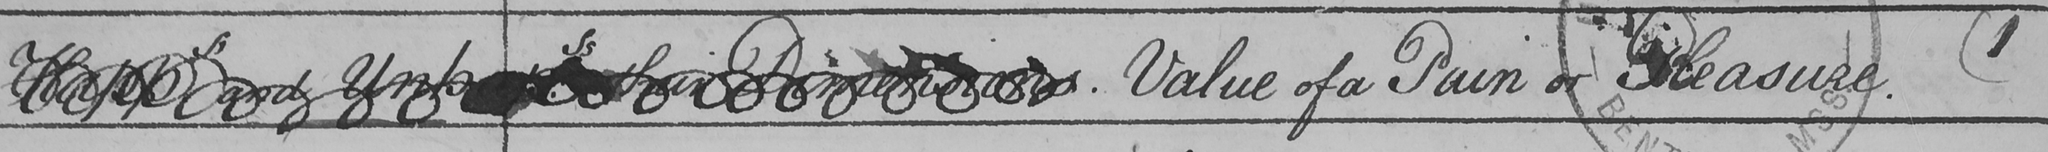Can you tell me what this handwritten text says? Happ : ss and Unhapp.ss Value of a Pain or Pleasure  ( 1 